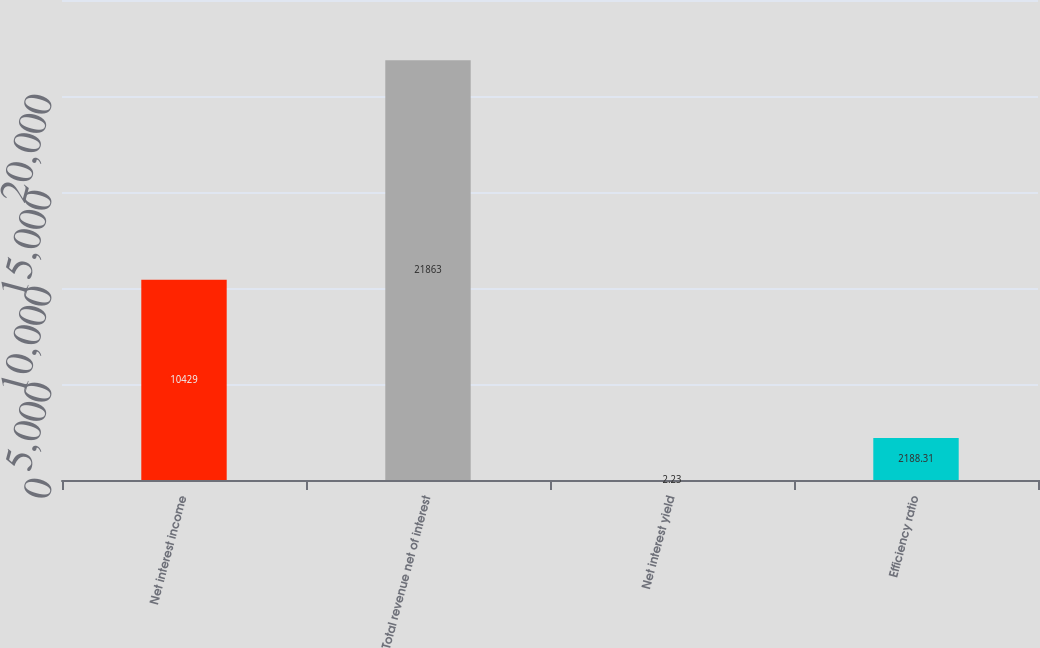Convert chart to OTSL. <chart><loc_0><loc_0><loc_500><loc_500><bar_chart><fcel>Net interest income<fcel>Total revenue net of interest<fcel>Net interest yield<fcel>Efficiency ratio<nl><fcel>10429<fcel>21863<fcel>2.23<fcel>2188.31<nl></chart> 